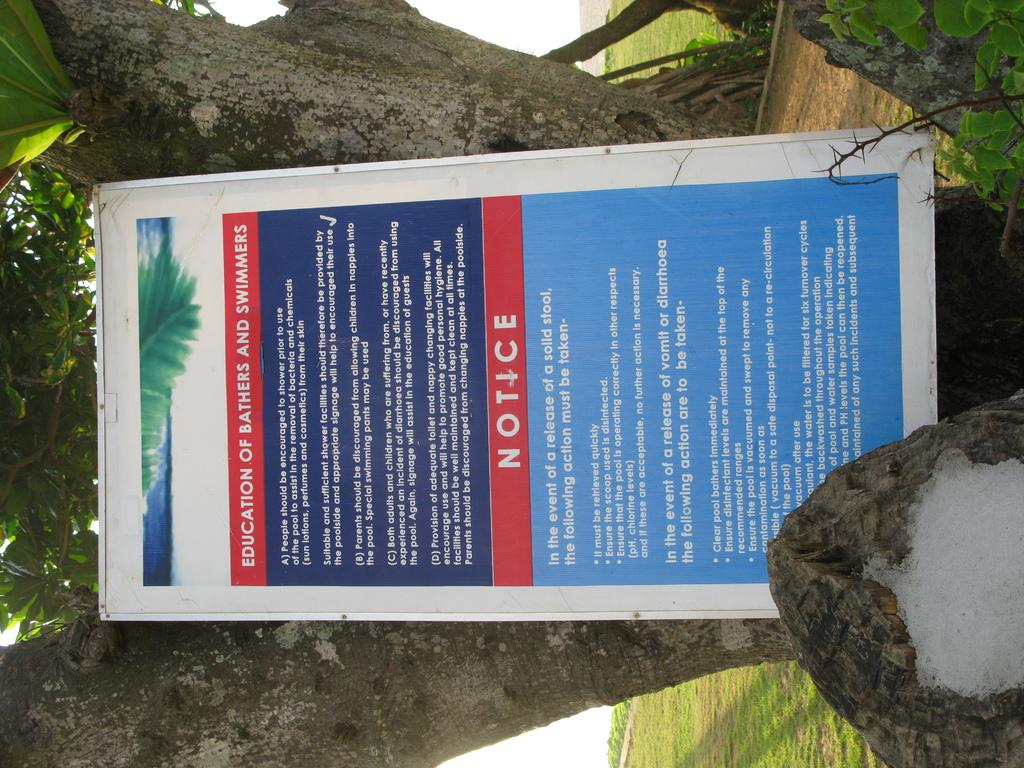What is the main object in the image? There is a board in the image. Where is the board located in relation to other objects? The board is in front of a tree. Reasoning: Let' Let's think step by step in order to produce the conversation. We start by identifying the main subject of the image, which is the board. Then, we describe its location in relation to other objects, which is in front of a tree. We ensure that each question is based on the provided facts and can be answered definitively. Absurd Question/Answer: What type of apparatus is being used by the cook to prepare the tiger in the image? There is no cook or tiger present in the image; it only features a board in front of a tree. 